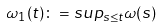<formula> <loc_0><loc_0><loc_500><loc_500>\omega _ { 1 } ( t ) \colon = s u p _ { s \leq t } \omega ( s )</formula> 